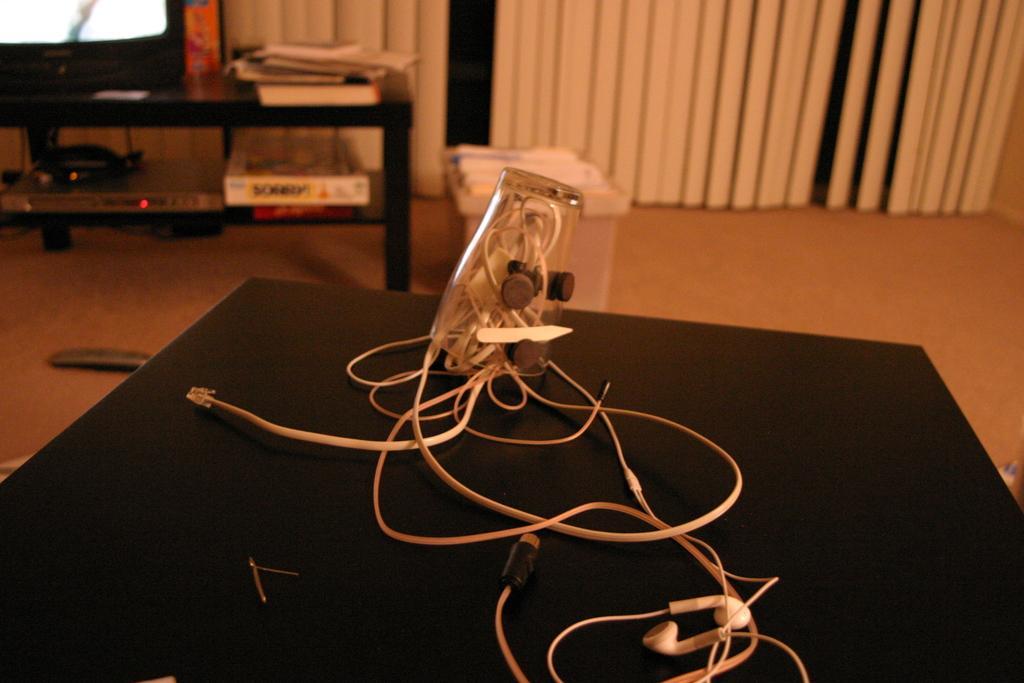In one or two sentences, can you explain what this image depicts? In this image in front there is a table and on top of it there is a glass in which there are earphones. At the bottom of the image there is a tub and a remote. In the background of the image there are curtains. In front of the curtains there is a table. On top of the table there is a TV, books, DVD player, stabilizer. 